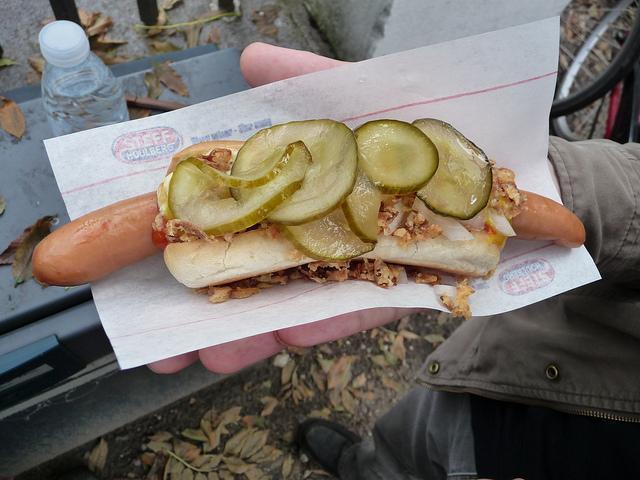What type of solution were the cucumbers soaked in?
Choose the right answer and clarify with the format: 'Answer: answer
Rationale: rationale.'
Options: Yogurt, mustard, syrup, brine. Answer: brine.
Rationale: The cucumbers are soaked in vinegar. 